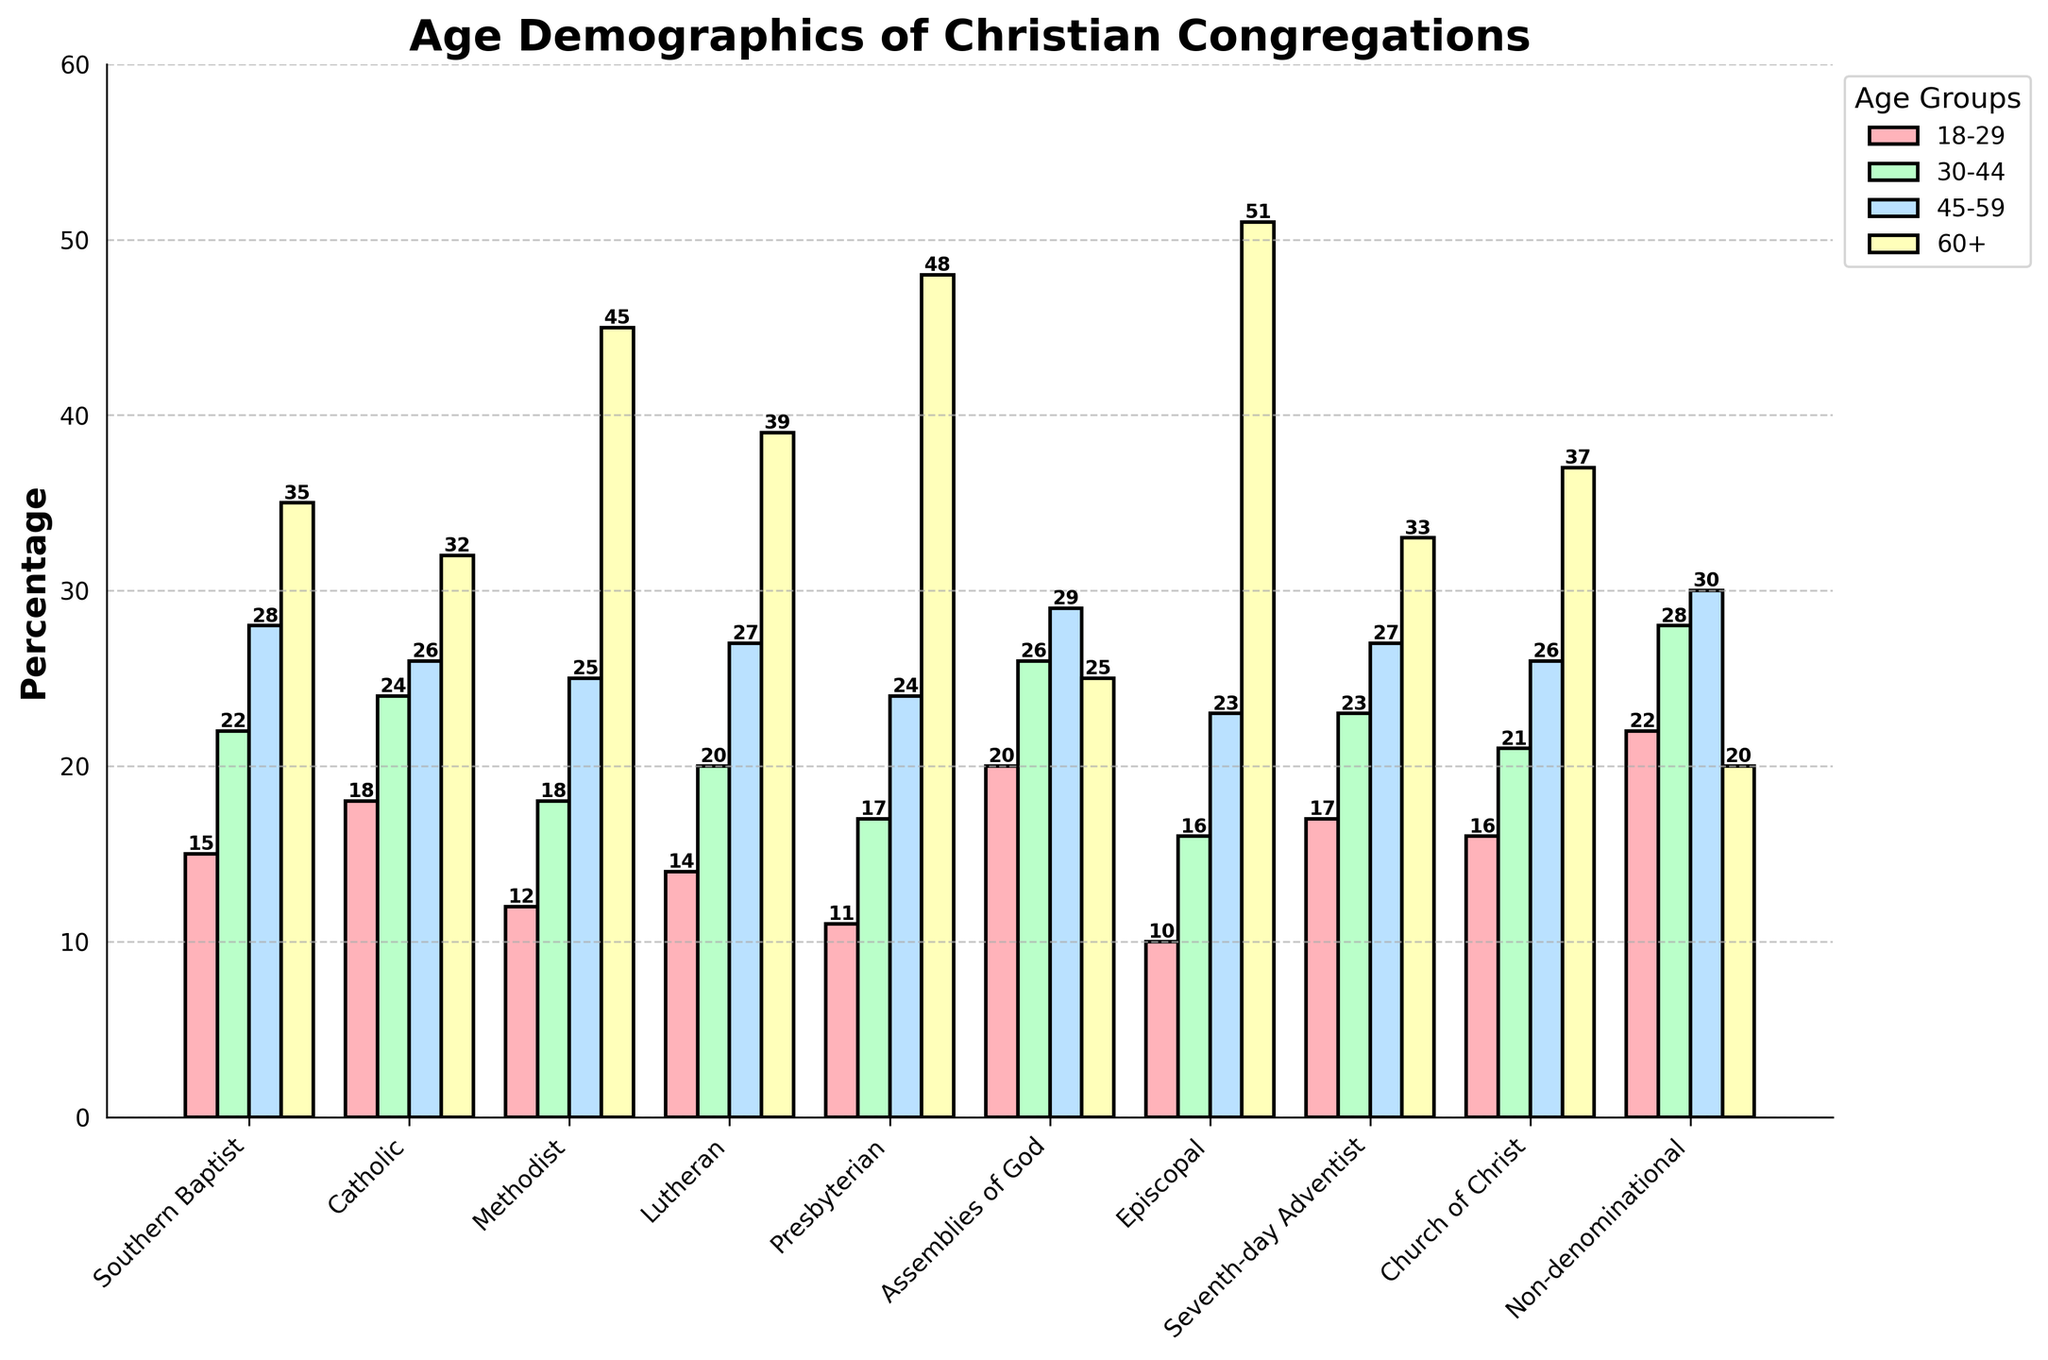Which denomination has the highest percentage of members aged 60 and above? Look for the bar representing the 60+ age group and identify the tallest one among all denominations. The tallest bar in the 60+ age group is for the Episcopal denomination.
Answer: Episcopal Which denomination has the smallest percentage of members aged 18-29? Look at the bar heights for the 18-29 age group across all denominations and pinpoint the shortest one. The shortest bar in the 18-29 age group is for the Episcopal denomination.
Answer: Episcopal What is the difference in percentage between the youngest and oldest age groups in the Non-denominational denomination? Find the heights of the bars for the 18-29 and 60+ age groups for the Non-denominational denomination. Subtract the height of the 60+ bar (20) from the height of the 18-29 bar (22). The difference is 22 - 20 = 2.
Answer: 2 What is the average percentage of members aged 30-44 across all denominations? Add the percentages of the 30-44 age group for all denominations and divide by the total number of denominations (10). (22+24+18+20+17+26+16+23+21+28)/10 = 21.5
Answer: 21.5 Which age group has the most consistent (similar) percentage across all denominations, and what does that tell us? Compare the bar heights for each age group across all denominations. The 30-44 age group has relatively similar percentages across denominations, which suggests this age group is more evenly distributed among different Christian congregations.
Answer: 30-44 age group How many denominations have the 60+ age group as their largest percentage? Check the height of the bars for each denomination to see if the 60+ age group bar is the tallest. The denominations are Methodist, Lutheran, Presbyterian, and Episcopal.
Answer: 4 What is the combined percentage of members aged 18-29 and 30-44 in the Assemblies of God? Add the percentages of the 18-29 and 30-44 age groups for the Assemblies of God denomination. 20 + 26 = 46.
Answer: 46 What trend can you observe about the age distribution for the Southern Baptist denomination? Look at the Southern Baptist bar heights for all age groups. The percentage gradually increases with age, showing that there are more older members than younger members in the Southern Baptist denomination.
Answer: Increasing with age Which denomination has the highest combined percentage for the two oldest age groups (45-59 and 60+)? Add the percentages for the 45-59 and 60+ age groups in each denomination and identify the highest total. Episcopal: 23+51=74, which is the highest combined percentage.
Answer: Episcopal 